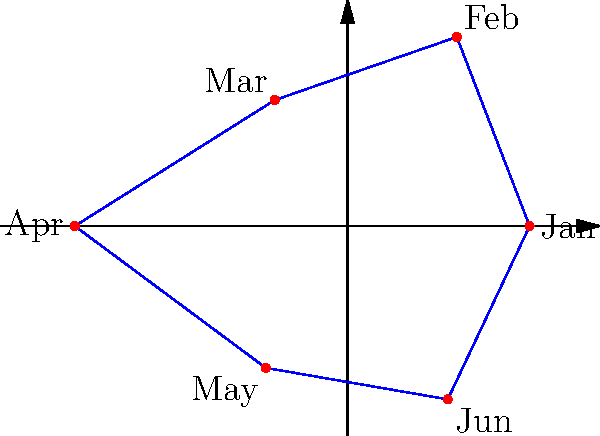The graph above represents your monthly expenses for the first half of the year as a regular hexagon. If you were to create a chatbot that could rotate and reflect this graph to show different perspectives of your financial data, what would be the order of the dihedral group representing all possible symmetries of this hexagonal graph? To determine the order of the dihedral group for a hexagonal graph, we need to follow these steps:

1. Identify the shape: The graph is a regular hexagon.

2. Recall the formula for the order of a dihedral group:
   For a regular n-gon, the order of the dihedral group $D_n$ is given by $|D_n| = 2n$.

3. In this case, we have a hexagon, so $n = 6$.

4. Apply the formula:
   $|D_6| = 2 * 6 = 12$

5. Interpret the result:
   The order 12 means there are 12 symmetries in total:
   - 6 rotational symmetries (including the identity rotation)
   - 6 reflection symmetries

These symmetries represent all possible ways to rotate or flip the hexagonal graph while maintaining its shape, which could be useful for viewing the financial data from different perspectives in a chatbot interface.
Answer: 12 